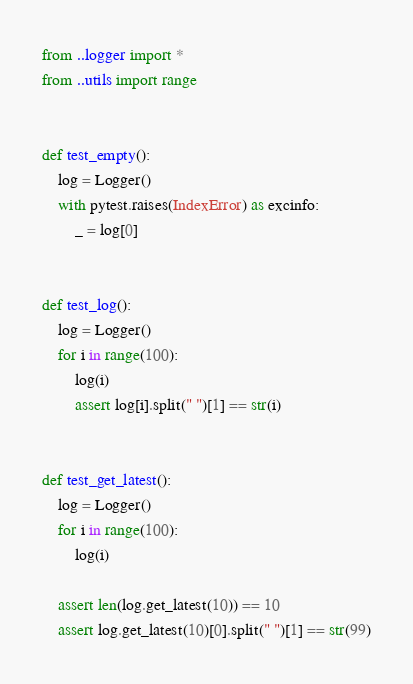<code> <loc_0><loc_0><loc_500><loc_500><_Python_>
from ..logger import *
from ..utils import range


def test_empty():
    log = Logger()
    with pytest.raises(IndexError) as excinfo:
        _ = log[0]


def test_log():
    log = Logger()
    for i in range(100):
        log(i)
        assert log[i].split(" ")[1] == str(i)


def test_get_latest():
    log = Logger()
    for i in range(100):
        log(i)

    assert len(log.get_latest(10)) == 10
    assert log.get_latest(10)[0].split(" ")[1] == str(99)
</code> 